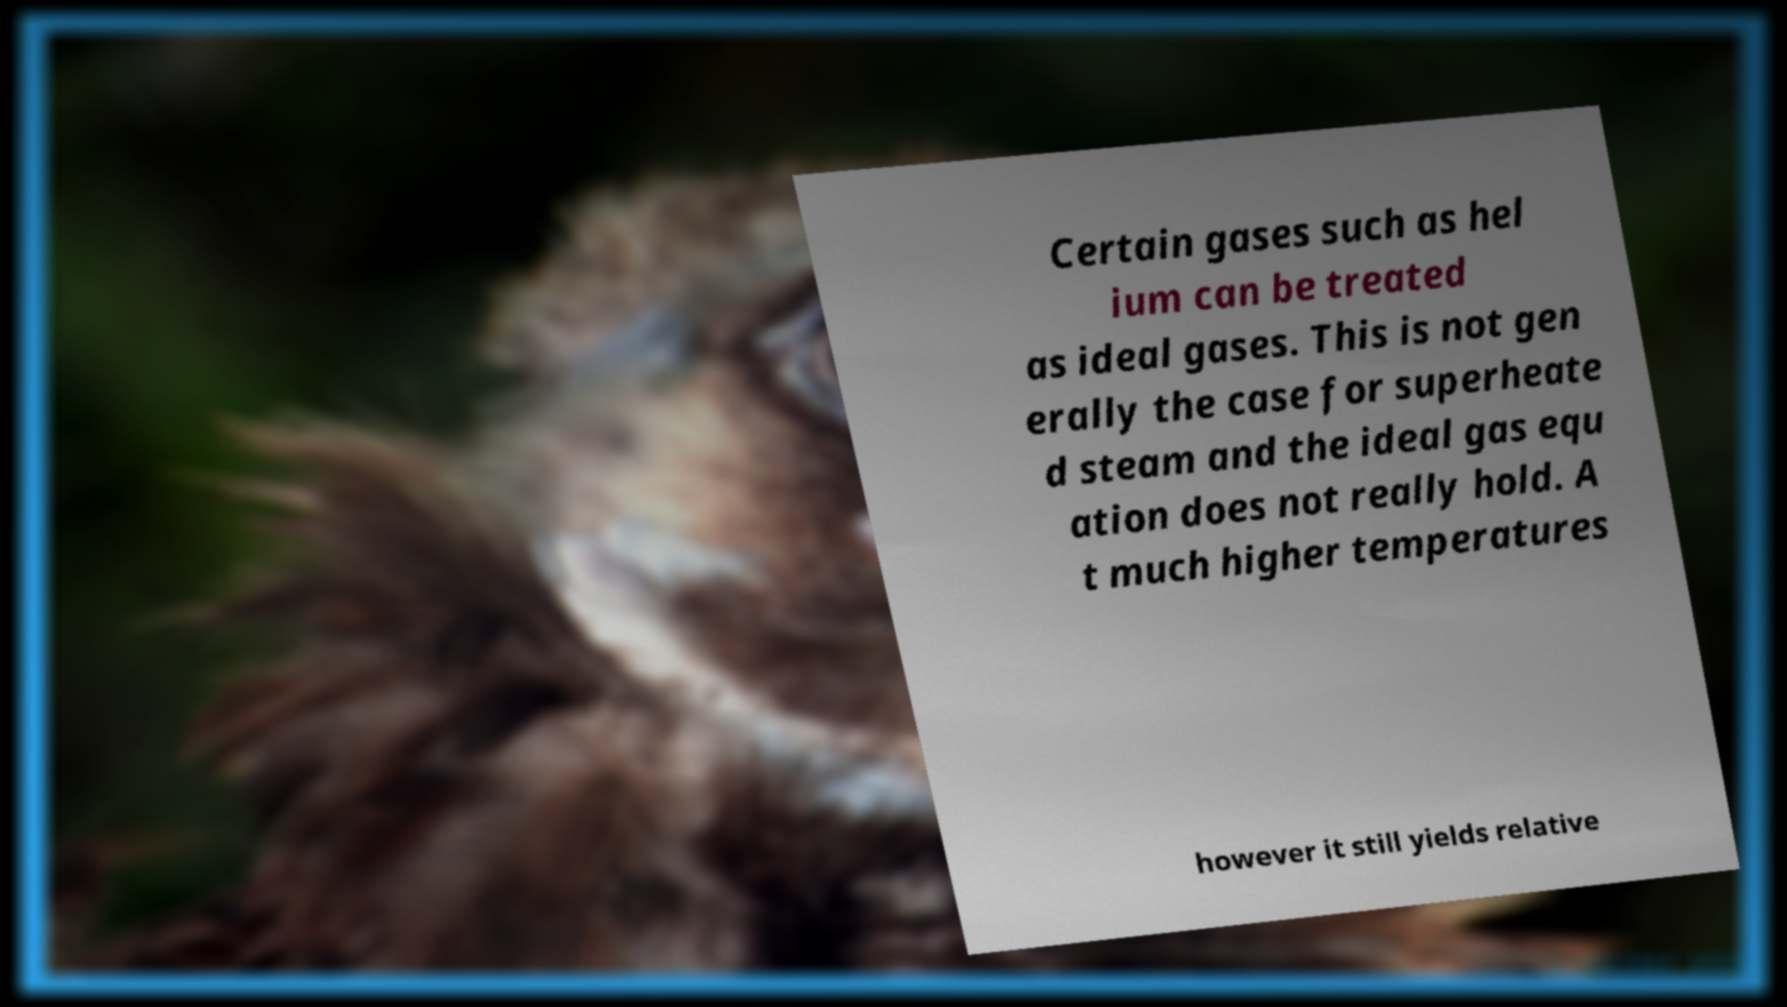Can you accurately transcribe the text from the provided image for me? Certain gases such as hel ium can be treated as ideal gases. This is not gen erally the case for superheate d steam and the ideal gas equ ation does not really hold. A t much higher temperatures however it still yields relative 